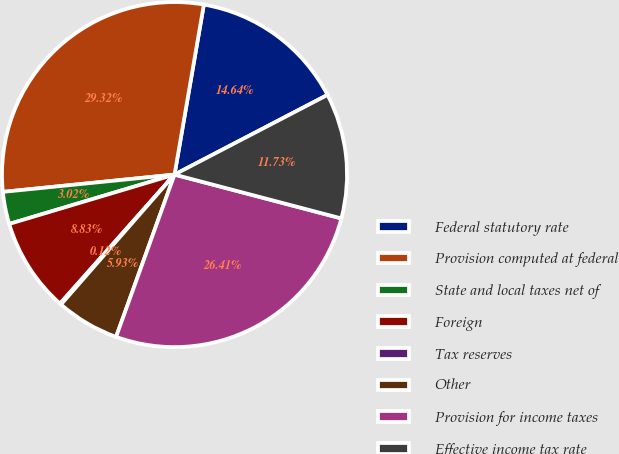Convert chart to OTSL. <chart><loc_0><loc_0><loc_500><loc_500><pie_chart><fcel>Federal statutory rate<fcel>Provision computed at federal<fcel>State and local taxes net of<fcel>Foreign<fcel>Tax reserves<fcel>Other<fcel>Provision for income taxes<fcel>Effective income tax rate<nl><fcel>14.64%<fcel>29.32%<fcel>3.02%<fcel>8.83%<fcel>0.12%<fcel>5.93%<fcel>26.41%<fcel>11.73%<nl></chart> 